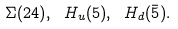Convert formula to latex. <formula><loc_0><loc_0><loc_500><loc_500>\Sigma ( 2 4 ) , \ H _ { u } ( 5 ) , \ H _ { d } ( \bar { 5 } ) .</formula> 